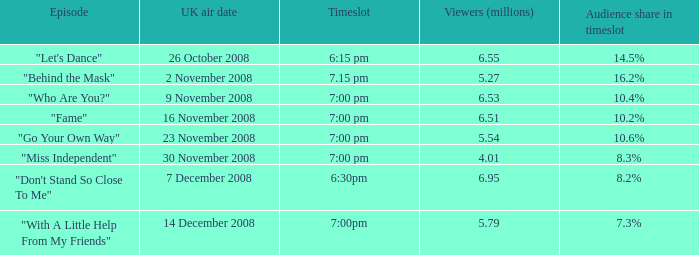Name the total number of timeslot for number 1 1.0. 